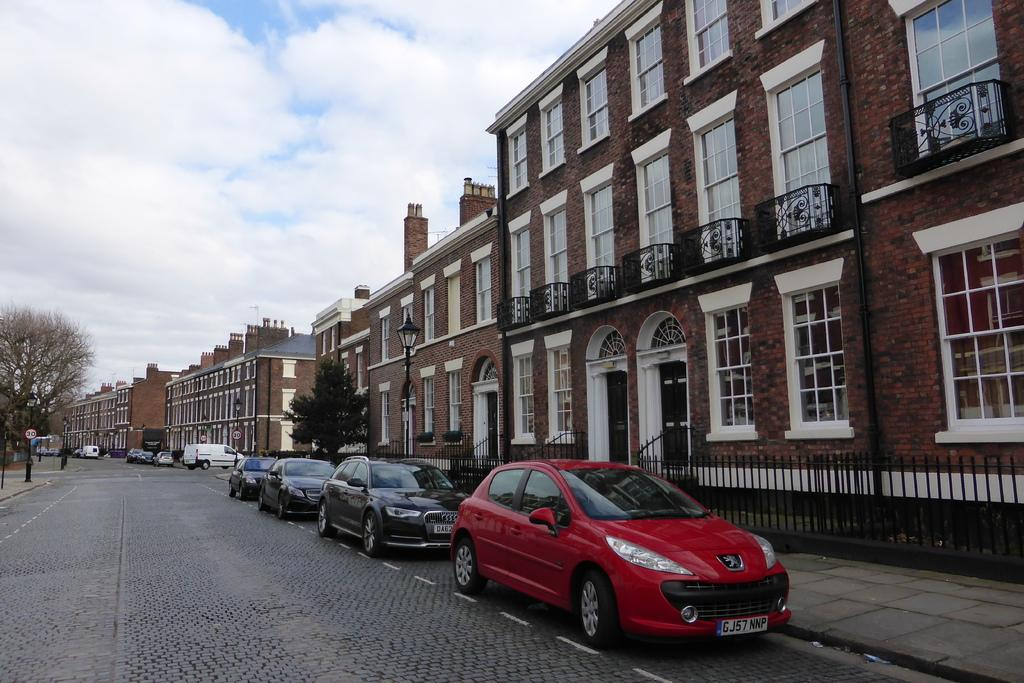What can be seen moving on the road in the image? There are vehicles on the road in the image. What type of buildings can be seen in the image? There are buildings in brown color in the image. What are the tall, thin structures with lights on them in the image? Light poles are visible in the image. What type of vegetation is present in the image? There are trees in green color in the image. What is the color of the sky in the image? The sky is in blue and white color in the image. What size is the cannon in the image? There is no cannon present in the image. How many needles are there in the image? There are no needles present in the image. 